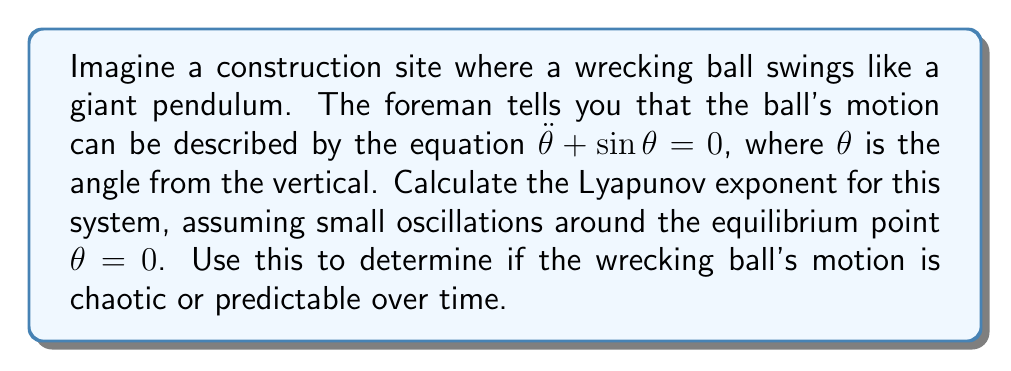Show me your answer to this math problem. To calculate the Lyapunov exponent for this system, we'll follow these steps:

1) First, we linearize the system around the equilibrium point $\theta = 0$. For small angles, $\sin \theta \approx \theta$.

2) The linearized equation becomes:
   $$\ddot{\theta} + \theta = 0$$

3) We can rewrite this as a system of first-order equations:
   $$\begin{aligned}
   \dot{\theta} &= \omega \\
   \dot{\omega} &= -\theta
   \end{aligned}$$

4) The Jacobian matrix for this system is:
   $$J = \begin{pmatrix}
   0 & 1 \\
   -1 & 0
   \end{pmatrix}$$

5) The eigenvalues of J are given by:
   $$\det(J - \lambda I) = \begin{vmatrix}
   -\lambda & 1 \\
   -1 & -\lambda
   \end{vmatrix} = \lambda^2 + 1 = 0$$

6) Solving this, we get:
   $$\lambda = \pm i$$

7) The Lyapunov exponent is the real part of the eigenvalues. In this case, both eigenvalues are purely imaginary, so:

   $$\lambda_{Lyapunov} = \Re(\lambda) = 0$$

8) A Lyapunov exponent of 0 indicates that nearby trajectories neither converge nor diverge exponentially over time.
Answer: $\lambda_{Lyapunov} = 0$, indicating non-chaotic, predictable motion. 